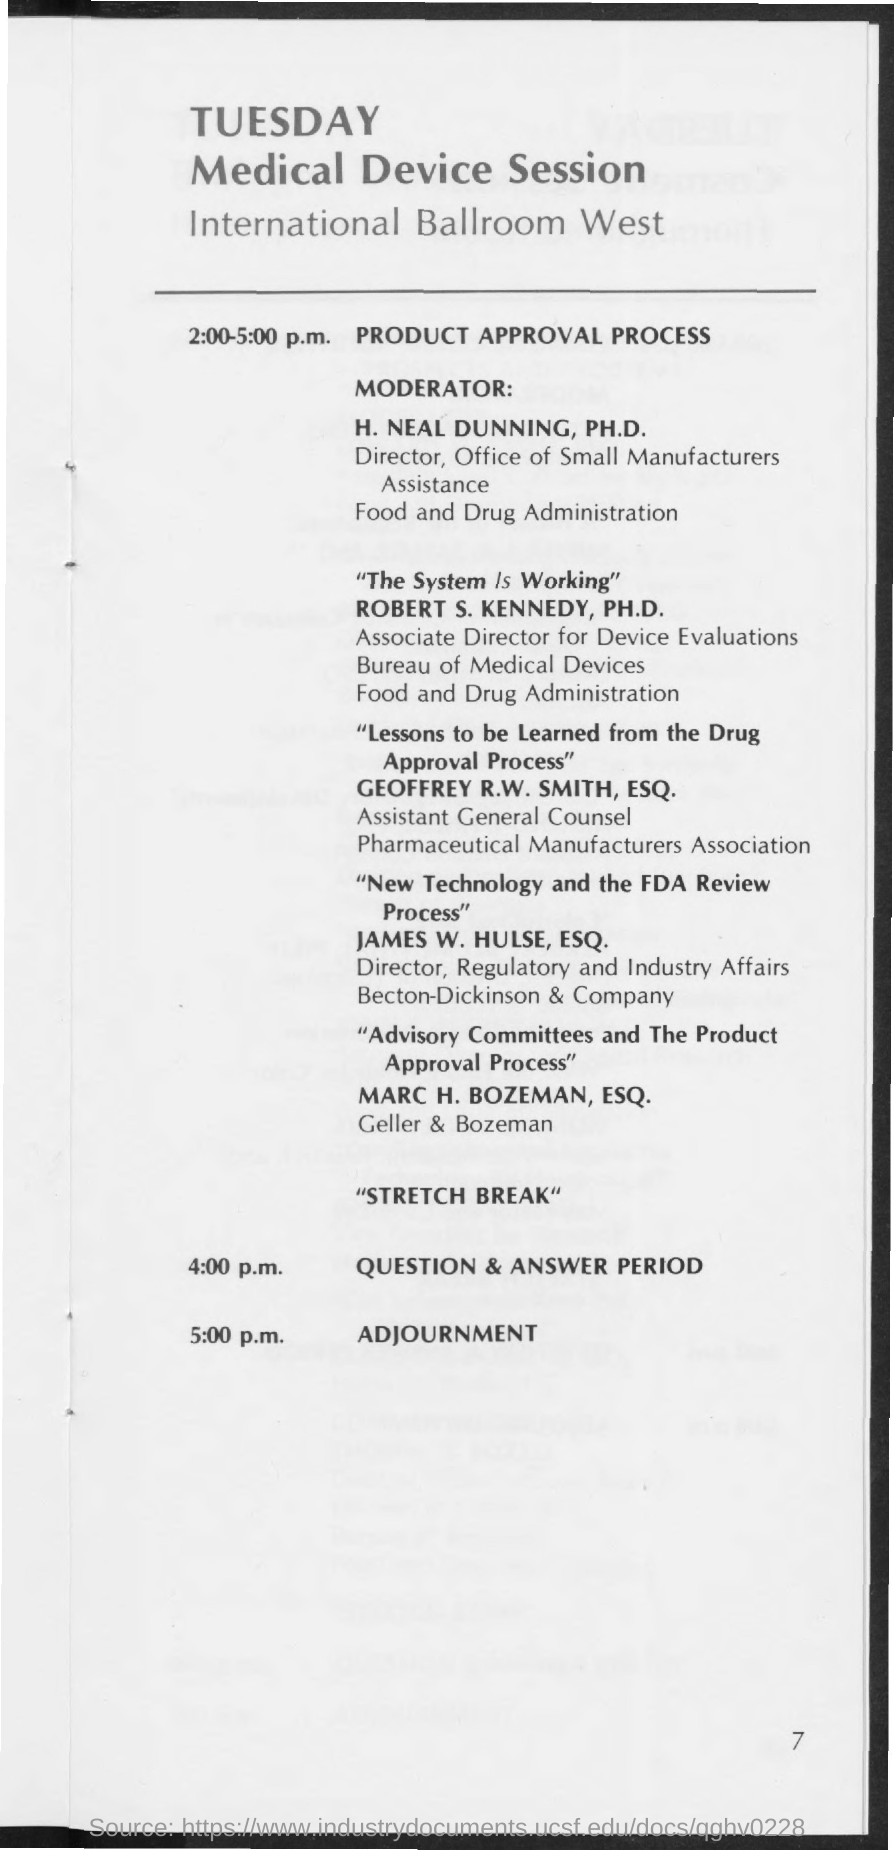Indicate a few pertinent items in this graphic. The session for the Product Approval Process is scheduled to occur from 2:00-5:00 p.m. The question and answer period is scheduled to take place at 4:00 PM. The adjournment is scheduled for 5:00 p.m. on... 